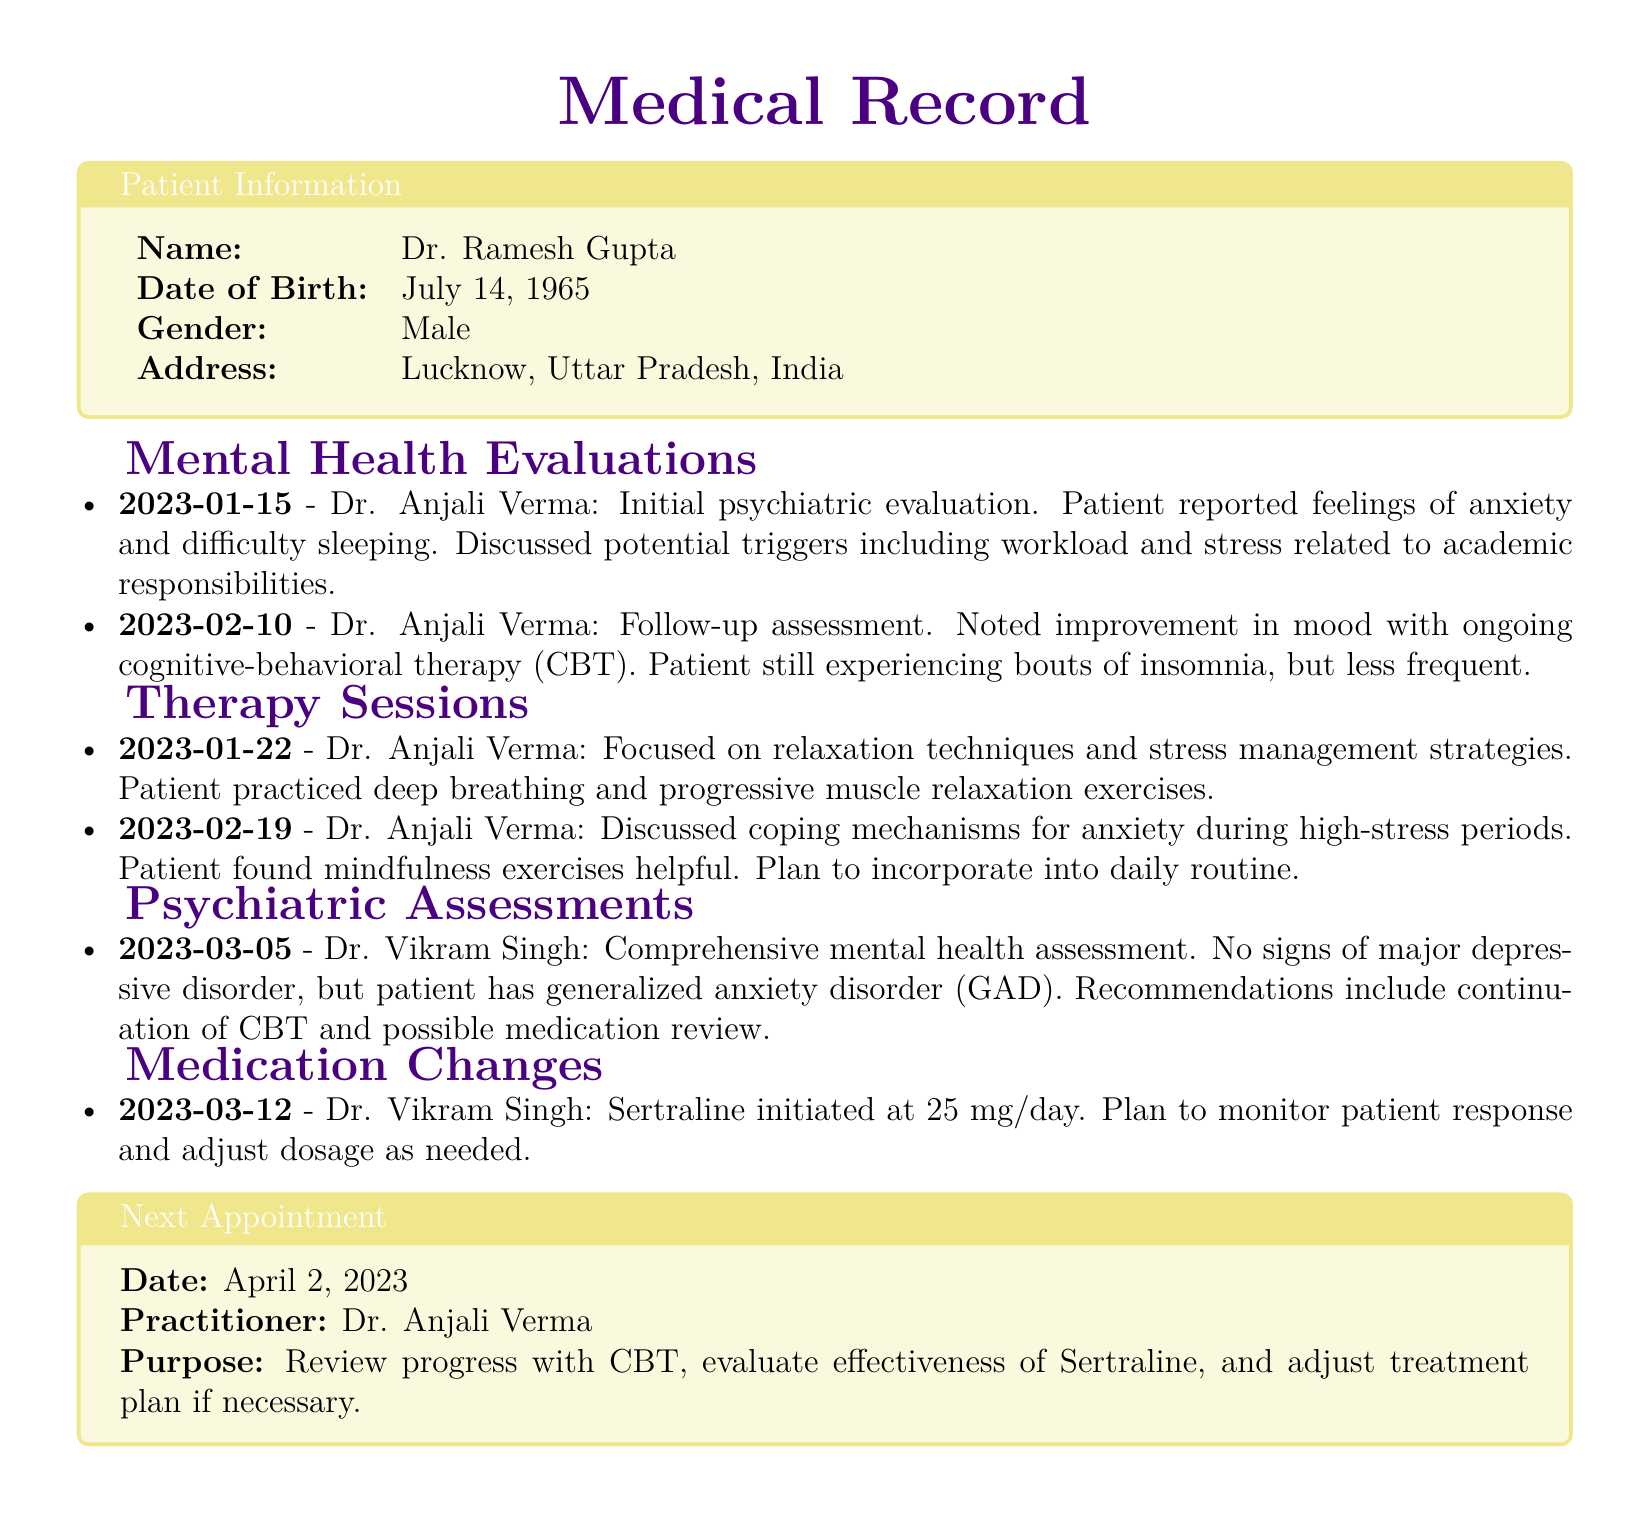what is the name of the patient? The patient's name is listed at the beginning of the document under Patient Information.
Answer: Dr. Ramesh Gupta when was the initial psychiatric evaluation conducted? The date of the initial psychiatric evaluation is specified in the Mental Health Evaluations section.
Answer: 2023-01-15 who conducted the follow-up assessment? The practitioner performing the follow-up assessment is clearly stated in the Mental Health Evaluations section.
Answer: Dr. Anjali Verma what medication was initiated on March 12, 2023? The Medication Changes section indicates the type of medication started on that date.
Answer: Sertraline what is the purpose of the next appointment? The purpose of the next appointment is detailed at the end of the document in the Next Appointment box.
Answer: Review progress with CBT, evaluate effectiveness of Sertraline, and adjust treatment plan if necessary what therapy techniques were focused on during the session on January 22, 2023? The therapy sessions section describes the techniques practiced during that session.
Answer: Relaxation techniques and stress management strategies how often did the patient experience bouts of insomnia according to the follow-up assessment? The follow-up assessment mentions the frequency of insomnia, which indicates the patient's condition.
Answer: Less frequent what type of therapy is the patient receiving? The type of therapy being utilized for treatment is specified in the Therapy Sessions section.
Answer: Cognitive-behavioral therapy (CBT) 